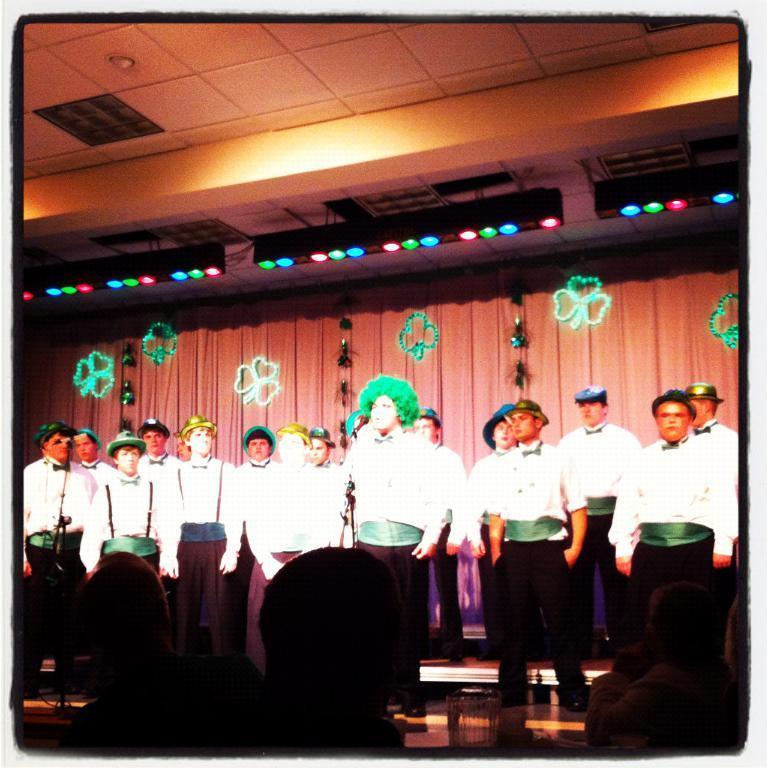How would you summarize this image in a sentence or two? In this picture I can see number of men in front, who are standing and I see that all of them are wearing same dress. In the background I can see the curtains on which there are designs and on the top of this picture I can see the ceiling and I see the lights which are colorful. On the bottom of this picture I see that it is dark. 